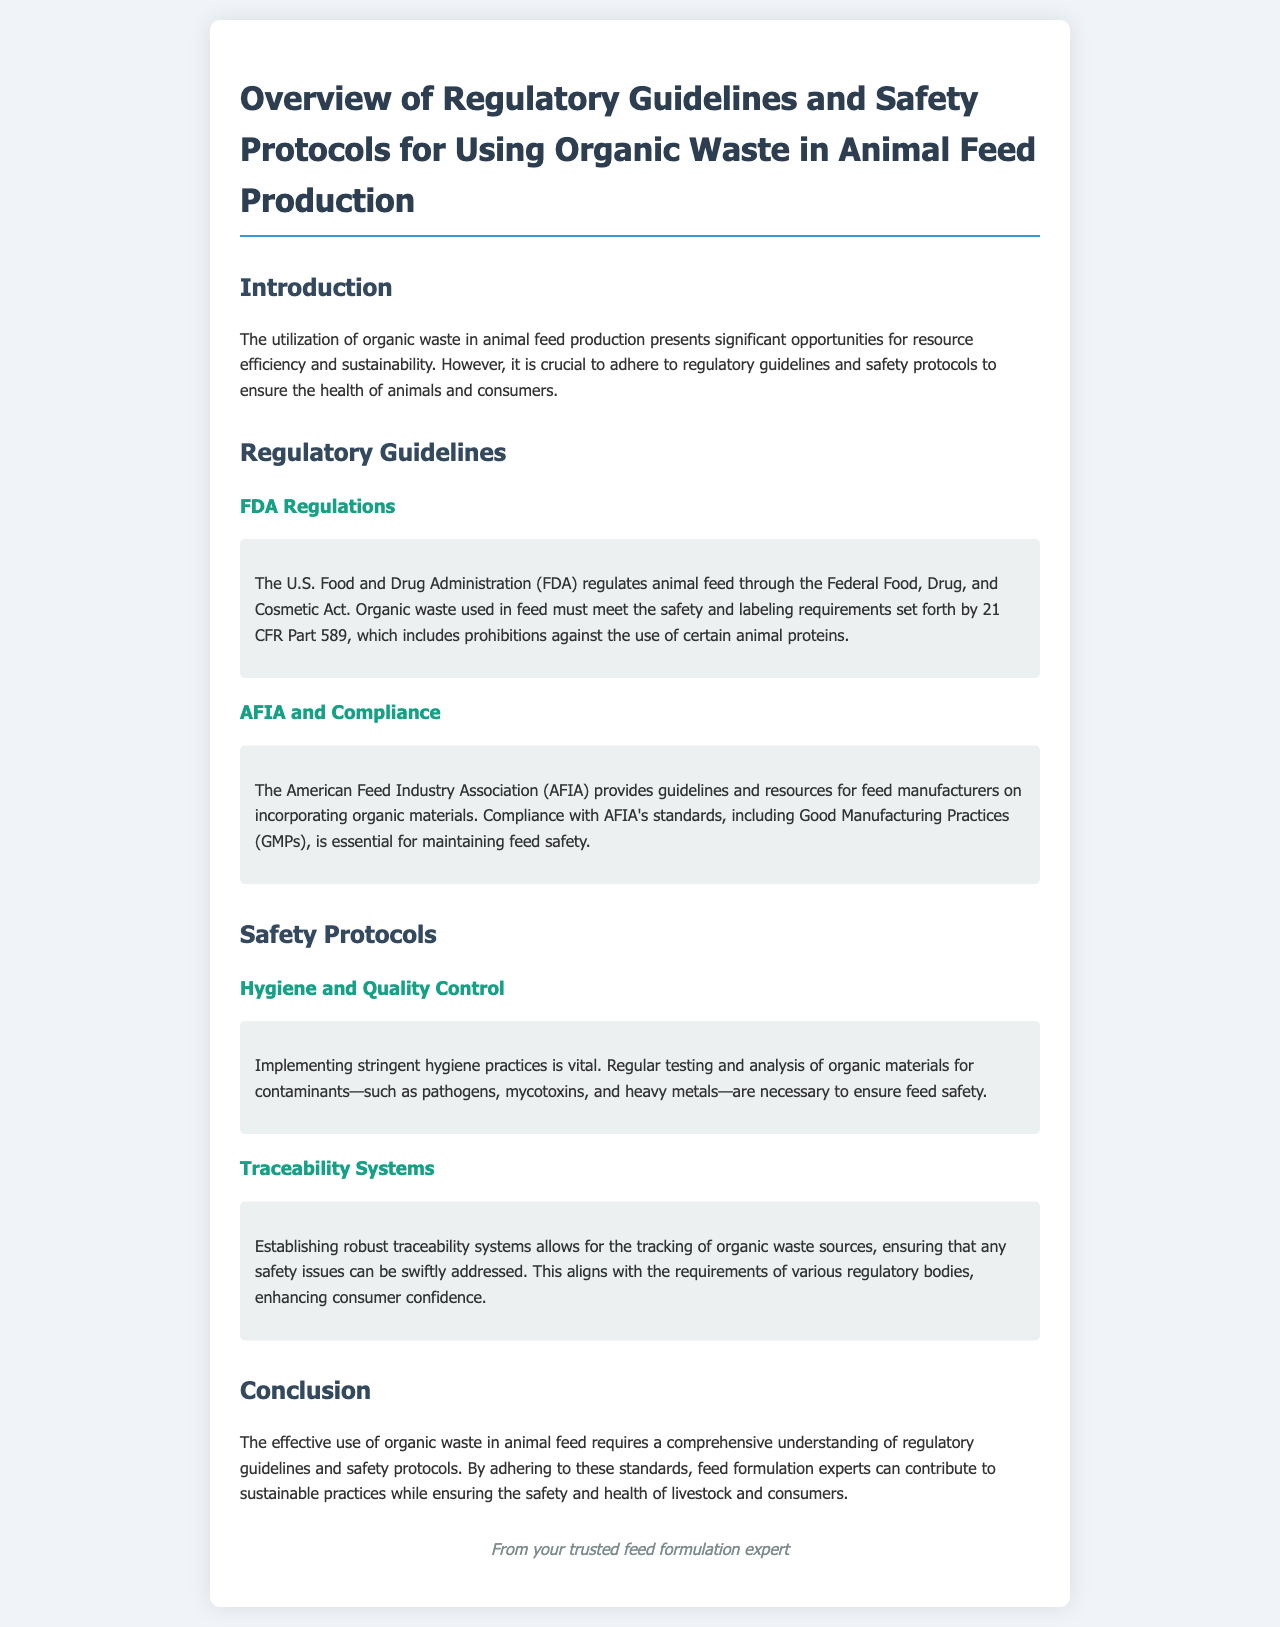What regulatory body oversees animal feed safety? The document specifies that the U.S. Food and Drug Administration (FDA) regulates animal feed through the Federal Food, Drug, and Cosmetic Act.
Answer: FDA What does 21 CFR Part 589 prohibit? The document states that 21 CFR Part 589 includes prohibitions against the use of certain animal proteins.
Answer: Certain animal proteins What organization provides guidelines for incorporating organic materials in feed? The document mentions the American Feed Industry Association (AFIA) as the organization providing such guidelines.
Answer: AFIA What are essential for maintaining feed safety? The document notes that compliance with AFIA's standards, including Good Manufacturing Practices (GMPs), is essential for maintaining feed safety.
Answer: Good Manufacturing Practices What contaminants must organic materials be tested for? The document lists pathogens, mycotoxins, and heavy metals as contaminants that need testing.
Answer: Pathogens, mycotoxins, heavy metals Why are traceability systems important? The document explains that traceability systems enhance consumer confidence and allow for quick addressing of any safety issues.
Answer: Enhance consumer confidence What is the main objective of using organic waste in animal feed production? The document emphasizes that organic waste utilization presents significant opportunities for resource efficiency and sustainability.
Answer: Resource efficiency and sustainability What is the final section of the document titled? The document concludes with a section titled "Conclusion".
Answer: Conclusion 